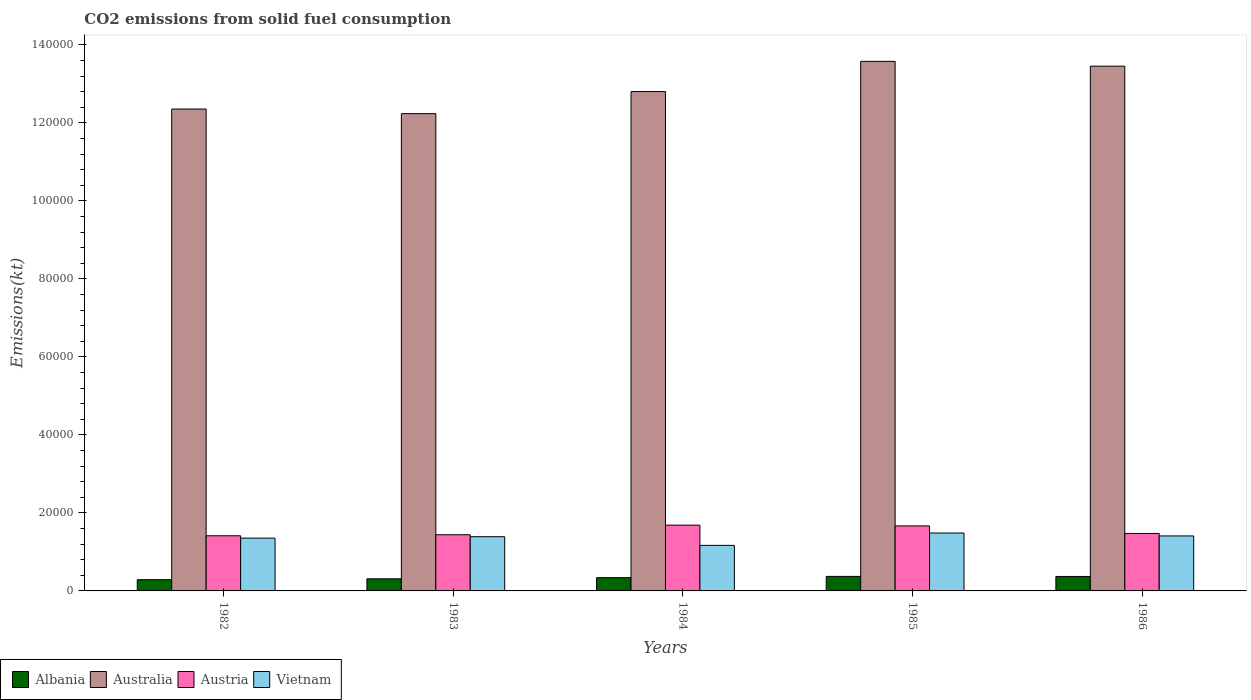How many groups of bars are there?
Offer a terse response. 5. Are the number of bars per tick equal to the number of legend labels?
Offer a terse response. Yes. Are the number of bars on each tick of the X-axis equal?
Offer a very short reply. Yes. How many bars are there on the 5th tick from the right?
Provide a succinct answer. 4. In how many cases, is the number of bars for a given year not equal to the number of legend labels?
Give a very brief answer. 0. What is the amount of CO2 emitted in Australia in 1986?
Your response must be concise. 1.35e+05. Across all years, what is the maximum amount of CO2 emitted in Austria?
Provide a short and direct response. 1.69e+04. Across all years, what is the minimum amount of CO2 emitted in Albania?
Provide a succinct answer. 2882.26. What is the total amount of CO2 emitted in Albania in the graph?
Your answer should be very brief. 1.68e+04. What is the difference between the amount of CO2 emitted in Austria in 1982 and that in 1983?
Your answer should be very brief. -267.69. What is the difference between the amount of CO2 emitted in Austria in 1982 and the amount of CO2 emitted in Australia in 1984?
Keep it short and to the point. -1.14e+05. What is the average amount of CO2 emitted in Australia per year?
Provide a short and direct response. 1.29e+05. In the year 1982, what is the difference between the amount of CO2 emitted in Vietnam and amount of CO2 emitted in Austria?
Your answer should be compact. -597.72. In how many years, is the amount of CO2 emitted in Austria greater than 20000 kt?
Provide a succinct answer. 0. What is the ratio of the amount of CO2 emitted in Albania in 1983 to that in 1985?
Give a very brief answer. 0.83. Is the difference between the amount of CO2 emitted in Vietnam in 1984 and 1986 greater than the difference between the amount of CO2 emitted in Austria in 1984 and 1986?
Your response must be concise. No. What is the difference between the highest and the second highest amount of CO2 emitted in Albania?
Offer a terse response. 14.67. What is the difference between the highest and the lowest amount of CO2 emitted in Austria?
Offer a terse response. 2728.25. Is it the case that in every year, the sum of the amount of CO2 emitted in Austria and amount of CO2 emitted in Australia is greater than the sum of amount of CO2 emitted in Albania and amount of CO2 emitted in Vietnam?
Offer a very short reply. Yes. What does the 4th bar from the left in 1985 represents?
Provide a short and direct response. Vietnam. How many bars are there?
Your response must be concise. 20. Are all the bars in the graph horizontal?
Offer a terse response. No. How many years are there in the graph?
Ensure brevity in your answer.  5. Are the values on the major ticks of Y-axis written in scientific E-notation?
Make the answer very short. No. Where does the legend appear in the graph?
Your response must be concise. Bottom left. How many legend labels are there?
Ensure brevity in your answer.  4. How are the legend labels stacked?
Make the answer very short. Horizontal. What is the title of the graph?
Your answer should be compact. CO2 emissions from solid fuel consumption. What is the label or title of the Y-axis?
Your response must be concise. Emissions(kt). What is the Emissions(kt) in Albania in 1982?
Your answer should be very brief. 2882.26. What is the Emissions(kt) in Australia in 1982?
Your response must be concise. 1.24e+05. What is the Emissions(kt) in Austria in 1982?
Provide a succinct answer. 1.41e+04. What is the Emissions(kt) of Vietnam in 1982?
Your answer should be compact. 1.35e+04. What is the Emissions(kt) in Albania in 1983?
Offer a very short reply. 3105.95. What is the Emissions(kt) of Australia in 1983?
Your answer should be compact. 1.22e+05. What is the Emissions(kt) of Austria in 1983?
Your response must be concise. 1.44e+04. What is the Emissions(kt) of Vietnam in 1983?
Your response must be concise. 1.39e+04. What is the Emissions(kt) of Albania in 1984?
Offer a terse response. 3402.98. What is the Emissions(kt) of Australia in 1984?
Ensure brevity in your answer.  1.28e+05. What is the Emissions(kt) in Austria in 1984?
Make the answer very short. 1.69e+04. What is the Emissions(kt) in Vietnam in 1984?
Make the answer very short. 1.17e+04. What is the Emissions(kt) of Albania in 1985?
Your response must be concise. 3725.67. What is the Emissions(kt) in Australia in 1985?
Make the answer very short. 1.36e+05. What is the Emissions(kt) of Austria in 1985?
Offer a terse response. 1.67e+04. What is the Emissions(kt) of Vietnam in 1985?
Make the answer very short. 1.49e+04. What is the Emissions(kt) of Albania in 1986?
Offer a terse response. 3711. What is the Emissions(kt) in Australia in 1986?
Give a very brief answer. 1.35e+05. What is the Emissions(kt) of Austria in 1986?
Offer a terse response. 1.47e+04. What is the Emissions(kt) of Vietnam in 1986?
Give a very brief answer. 1.41e+04. Across all years, what is the maximum Emissions(kt) of Albania?
Keep it short and to the point. 3725.67. Across all years, what is the maximum Emissions(kt) of Australia?
Offer a terse response. 1.36e+05. Across all years, what is the maximum Emissions(kt) of Austria?
Your response must be concise. 1.69e+04. Across all years, what is the maximum Emissions(kt) of Vietnam?
Your answer should be compact. 1.49e+04. Across all years, what is the minimum Emissions(kt) of Albania?
Your answer should be very brief. 2882.26. Across all years, what is the minimum Emissions(kt) of Australia?
Give a very brief answer. 1.22e+05. Across all years, what is the minimum Emissions(kt) in Austria?
Your response must be concise. 1.41e+04. Across all years, what is the minimum Emissions(kt) of Vietnam?
Give a very brief answer. 1.17e+04. What is the total Emissions(kt) in Albania in the graph?
Provide a short and direct response. 1.68e+04. What is the total Emissions(kt) of Australia in the graph?
Offer a terse response. 6.44e+05. What is the total Emissions(kt) of Austria in the graph?
Your response must be concise. 7.68e+04. What is the total Emissions(kt) in Vietnam in the graph?
Keep it short and to the point. 6.81e+04. What is the difference between the Emissions(kt) in Albania in 1982 and that in 1983?
Give a very brief answer. -223.69. What is the difference between the Emissions(kt) of Australia in 1982 and that in 1983?
Ensure brevity in your answer.  1184.44. What is the difference between the Emissions(kt) of Austria in 1982 and that in 1983?
Offer a terse response. -267.69. What is the difference between the Emissions(kt) in Vietnam in 1982 and that in 1983?
Your response must be concise. -359.37. What is the difference between the Emissions(kt) of Albania in 1982 and that in 1984?
Give a very brief answer. -520.71. What is the difference between the Emissions(kt) of Australia in 1982 and that in 1984?
Your answer should be compact. -4477.41. What is the difference between the Emissions(kt) in Austria in 1982 and that in 1984?
Your response must be concise. -2728.25. What is the difference between the Emissions(kt) in Vietnam in 1982 and that in 1984?
Your response must be concise. 1859.17. What is the difference between the Emissions(kt) in Albania in 1982 and that in 1985?
Your response must be concise. -843.41. What is the difference between the Emissions(kt) of Australia in 1982 and that in 1985?
Your response must be concise. -1.22e+04. What is the difference between the Emissions(kt) of Austria in 1982 and that in 1985?
Your answer should be compact. -2530.23. What is the difference between the Emissions(kt) of Vietnam in 1982 and that in 1985?
Make the answer very short. -1309.12. What is the difference between the Emissions(kt) of Albania in 1982 and that in 1986?
Provide a short and direct response. -828.74. What is the difference between the Emissions(kt) of Australia in 1982 and that in 1986?
Provide a succinct answer. -1.10e+04. What is the difference between the Emissions(kt) in Austria in 1982 and that in 1986?
Your answer should be compact. -597.72. What is the difference between the Emissions(kt) in Vietnam in 1982 and that in 1986?
Your answer should be very brief. -561.05. What is the difference between the Emissions(kt) in Albania in 1983 and that in 1984?
Give a very brief answer. -297.03. What is the difference between the Emissions(kt) in Australia in 1983 and that in 1984?
Make the answer very short. -5661.85. What is the difference between the Emissions(kt) in Austria in 1983 and that in 1984?
Your answer should be compact. -2460.56. What is the difference between the Emissions(kt) in Vietnam in 1983 and that in 1984?
Offer a terse response. 2218.53. What is the difference between the Emissions(kt) of Albania in 1983 and that in 1985?
Offer a terse response. -619.72. What is the difference between the Emissions(kt) of Australia in 1983 and that in 1985?
Provide a short and direct response. -1.34e+04. What is the difference between the Emissions(kt) of Austria in 1983 and that in 1985?
Your response must be concise. -2262.54. What is the difference between the Emissions(kt) of Vietnam in 1983 and that in 1985?
Your response must be concise. -949.75. What is the difference between the Emissions(kt) of Albania in 1983 and that in 1986?
Provide a short and direct response. -605.05. What is the difference between the Emissions(kt) of Australia in 1983 and that in 1986?
Offer a terse response. -1.22e+04. What is the difference between the Emissions(kt) in Austria in 1983 and that in 1986?
Offer a very short reply. -330.03. What is the difference between the Emissions(kt) of Vietnam in 1983 and that in 1986?
Offer a very short reply. -201.69. What is the difference between the Emissions(kt) in Albania in 1984 and that in 1985?
Provide a succinct answer. -322.7. What is the difference between the Emissions(kt) of Australia in 1984 and that in 1985?
Provide a short and direct response. -7748.37. What is the difference between the Emissions(kt) in Austria in 1984 and that in 1985?
Offer a terse response. 198.02. What is the difference between the Emissions(kt) of Vietnam in 1984 and that in 1985?
Offer a very short reply. -3168.29. What is the difference between the Emissions(kt) of Albania in 1984 and that in 1986?
Provide a succinct answer. -308.03. What is the difference between the Emissions(kt) in Australia in 1984 and that in 1986?
Keep it short and to the point. -6516.26. What is the difference between the Emissions(kt) in Austria in 1984 and that in 1986?
Your answer should be very brief. 2130.53. What is the difference between the Emissions(kt) of Vietnam in 1984 and that in 1986?
Ensure brevity in your answer.  -2420.22. What is the difference between the Emissions(kt) of Albania in 1985 and that in 1986?
Your answer should be compact. 14.67. What is the difference between the Emissions(kt) of Australia in 1985 and that in 1986?
Keep it short and to the point. 1232.11. What is the difference between the Emissions(kt) in Austria in 1985 and that in 1986?
Provide a succinct answer. 1932.51. What is the difference between the Emissions(kt) of Vietnam in 1985 and that in 1986?
Provide a succinct answer. 748.07. What is the difference between the Emissions(kt) of Albania in 1982 and the Emissions(kt) of Australia in 1983?
Make the answer very short. -1.20e+05. What is the difference between the Emissions(kt) in Albania in 1982 and the Emissions(kt) in Austria in 1983?
Make the answer very short. -1.15e+04. What is the difference between the Emissions(kt) in Albania in 1982 and the Emissions(kt) in Vietnam in 1983?
Ensure brevity in your answer.  -1.10e+04. What is the difference between the Emissions(kt) of Australia in 1982 and the Emissions(kt) of Austria in 1983?
Make the answer very short. 1.09e+05. What is the difference between the Emissions(kt) of Australia in 1982 and the Emissions(kt) of Vietnam in 1983?
Give a very brief answer. 1.10e+05. What is the difference between the Emissions(kt) of Austria in 1982 and the Emissions(kt) of Vietnam in 1983?
Your answer should be compact. 238.35. What is the difference between the Emissions(kt) of Albania in 1982 and the Emissions(kt) of Australia in 1984?
Provide a succinct answer. -1.25e+05. What is the difference between the Emissions(kt) in Albania in 1982 and the Emissions(kt) in Austria in 1984?
Your answer should be very brief. -1.40e+04. What is the difference between the Emissions(kt) of Albania in 1982 and the Emissions(kt) of Vietnam in 1984?
Ensure brevity in your answer.  -8800.8. What is the difference between the Emissions(kt) in Australia in 1982 and the Emissions(kt) in Austria in 1984?
Make the answer very short. 1.07e+05. What is the difference between the Emissions(kt) of Australia in 1982 and the Emissions(kt) of Vietnam in 1984?
Give a very brief answer. 1.12e+05. What is the difference between the Emissions(kt) of Austria in 1982 and the Emissions(kt) of Vietnam in 1984?
Offer a terse response. 2456.89. What is the difference between the Emissions(kt) in Albania in 1982 and the Emissions(kt) in Australia in 1985?
Your answer should be very brief. -1.33e+05. What is the difference between the Emissions(kt) in Albania in 1982 and the Emissions(kt) in Austria in 1985?
Provide a succinct answer. -1.38e+04. What is the difference between the Emissions(kt) in Albania in 1982 and the Emissions(kt) in Vietnam in 1985?
Keep it short and to the point. -1.20e+04. What is the difference between the Emissions(kt) in Australia in 1982 and the Emissions(kt) in Austria in 1985?
Offer a terse response. 1.07e+05. What is the difference between the Emissions(kt) of Australia in 1982 and the Emissions(kt) of Vietnam in 1985?
Give a very brief answer. 1.09e+05. What is the difference between the Emissions(kt) of Austria in 1982 and the Emissions(kt) of Vietnam in 1985?
Offer a terse response. -711.4. What is the difference between the Emissions(kt) in Albania in 1982 and the Emissions(kt) in Australia in 1986?
Your answer should be very brief. -1.32e+05. What is the difference between the Emissions(kt) of Albania in 1982 and the Emissions(kt) of Austria in 1986?
Provide a short and direct response. -1.19e+04. What is the difference between the Emissions(kt) in Albania in 1982 and the Emissions(kt) in Vietnam in 1986?
Your answer should be compact. -1.12e+04. What is the difference between the Emissions(kt) of Australia in 1982 and the Emissions(kt) of Austria in 1986?
Make the answer very short. 1.09e+05. What is the difference between the Emissions(kt) of Australia in 1982 and the Emissions(kt) of Vietnam in 1986?
Your response must be concise. 1.09e+05. What is the difference between the Emissions(kt) in Austria in 1982 and the Emissions(kt) in Vietnam in 1986?
Your answer should be very brief. 36.67. What is the difference between the Emissions(kt) in Albania in 1983 and the Emissions(kt) in Australia in 1984?
Ensure brevity in your answer.  -1.25e+05. What is the difference between the Emissions(kt) in Albania in 1983 and the Emissions(kt) in Austria in 1984?
Offer a terse response. -1.38e+04. What is the difference between the Emissions(kt) in Albania in 1983 and the Emissions(kt) in Vietnam in 1984?
Your answer should be very brief. -8577.11. What is the difference between the Emissions(kt) in Australia in 1983 and the Emissions(kt) in Austria in 1984?
Ensure brevity in your answer.  1.06e+05. What is the difference between the Emissions(kt) in Australia in 1983 and the Emissions(kt) in Vietnam in 1984?
Offer a terse response. 1.11e+05. What is the difference between the Emissions(kt) in Austria in 1983 and the Emissions(kt) in Vietnam in 1984?
Give a very brief answer. 2724.58. What is the difference between the Emissions(kt) of Albania in 1983 and the Emissions(kt) of Australia in 1985?
Offer a very short reply. -1.33e+05. What is the difference between the Emissions(kt) of Albania in 1983 and the Emissions(kt) of Austria in 1985?
Offer a very short reply. -1.36e+04. What is the difference between the Emissions(kt) of Albania in 1983 and the Emissions(kt) of Vietnam in 1985?
Offer a very short reply. -1.17e+04. What is the difference between the Emissions(kt) in Australia in 1983 and the Emissions(kt) in Austria in 1985?
Your response must be concise. 1.06e+05. What is the difference between the Emissions(kt) in Australia in 1983 and the Emissions(kt) in Vietnam in 1985?
Your response must be concise. 1.08e+05. What is the difference between the Emissions(kt) in Austria in 1983 and the Emissions(kt) in Vietnam in 1985?
Provide a succinct answer. -443.71. What is the difference between the Emissions(kt) of Albania in 1983 and the Emissions(kt) of Australia in 1986?
Your answer should be compact. -1.31e+05. What is the difference between the Emissions(kt) in Albania in 1983 and the Emissions(kt) in Austria in 1986?
Your response must be concise. -1.16e+04. What is the difference between the Emissions(kt) of Albania in 1983 and the Emissions(kt) of Vietnam in 1986?
Offer a terse response. -1.10e+04. What is the difference between the Emissions(kt) in Australia in 1983 and the Emissions(kt) in Austria in 1986?
Your answer should be very brief. 1.08e+05. What is the difference between the Emissions(kt) in Australia in 1983 and the Emissions(kt) in Vietnam in 1986?
Your answer should be very brief. 1.08e+05. What is the difference between the Emissions(kt) of Austria in 1983 and the Emissions(kt) of Vietnam in 1986?
Ensure brevity in your answer.  304.36. What is the difference between the Emissions(kt) of Albania in 1984 and the Emissions(kt) of Australia in 1985?
Offer a very short reply. -1.32e+05. What is the difference between the Emissions(kt) of Albania in 1984 and the Emissions(kt) of Austria in 1985?
Give a very brief answer. -1.33e+04. What is the difference between the Emissions(kt) in Albania in 1984 and the Emissions(kt) in Vietnam in 1985?
Make the answer very short. -1.14e+04. What is the difference between the Emissions(kt) of Australia in 1984 and the Emissions(kt) of Austria in 1985?
Make the answer very short. 1.11e+05. What is the difference between the Emissions(kt) of Australia in 1984 and the Emissions(kt) of Vietnam in 1985?
Give a very brief answer. 1.13e+05. What is the difference between the Emissions(kt) in Austria in 1984 and the Emissions(kt) in Vietnam in 1985?
Provide a short and direct response. 2016.85. What is the difference between the Emissions(kt) in Albania in 1984 and the Emissions(kt) in Australia in 1986?
Your response must be concise. -1.31e+05. What is the difference between the Emissions(kt) of Albania in 1984 and the Emissions(kt) of Austria in 1986?
Provide a succinct answer. -1.13e+04. What is the difference between the Emissions(kt) of Albania in 1984 and the Emissions(kt) of Vietnam in 1986?
Your answer should be compact. -1.07e+04. What is the difference between the Emissions(kt) in Australia in 1984 and the Emissions(kt) in Austria in 1986?
Provide a short and direct response. 1.13e+05. What is the difference between the Emissions(kt) in Australia in 1984 and the Emissions(kt) in Vietnam in 1986?
Your response must be concise. 1.14e+05. What is the difference between the Emissions(kt) in Austria in 1984 and the Emissions(kt) in Vietnam in 1986?
Your answer should be very brief. 2764.92. What is the difference between the Emissions(kt) of Albania in 1985 and the Emissions(kt) of Australia in 1986?
Provide a succinct answer. -1.31e+05. What is the difference between the Emissions(kt) in Albania in 1985 and the Emissions(kt) in Austria in 1986?
Your response must be concise. -1.10e+04. What is the difference between the Emissions(kt) of Albania in 1985 and the Emissions(kt) of Vietnam in 1986?
Your answer should be very brief. -1.04e+04. What is the difference between the Emissions(kt) of Australia in 1985 and the Emissions(kt) of Austria in 1986?
Offer a very short reply. 1.21e+05. What is the difference between the Emissions(kt) in Australia in 1985 and the Emissions(kt) in Vietnam in 1986?
Provide a succinct answer. 1.22e+05. What is the difference between the Emissions(kt) in Austria in 1985 and the Emissions(kt) in Vietnam in 1986?
Make the answer very short. 2566.9. What is the average Emissions(kt) of Albania per year?
Offer a terse response. 3365.57. What is the average Emissions(kt) of Australia per year?
Keep it short and to the point. 1.29e+05. What is the average Emissions(kt) in Austria per year?
Offer a terse response. 1.54e+04. What is the average Emissions(kt) of Vietnam per year?
Make the answer very short. 1.36e+04. In the year 1982, what is the difference between the Emissions(kt) of Albania and Emissions(kt) of Australia?
Provide a short and direct response. -1.21e+05. In the year 1982, what is the difference between the Emissions(kt) of Albania and Emissions(kt) of Austria?
Give a very brief answer. -1.13e+04. In the year 1982, what is the difference between the Emissions(kt) in Albania and Emissions(kt) in Vietnam?
Make the answer very short. -1.07e+04. In the year 1982, what is the difference between the Emissions(kt) in Australia and Emissions(kt) in Austria?
Your answer should be compact. 1.09e+05. In the year 1982, what is the difference between the Emissions(kt) of Australia and Emissions(kt) of Vietnam?
Keep it short and to the point. 1.10e+05. In the year 1982, what is the difference between the Emissions(kt) of Austria and Emissions(kt) of Vietnam?
Provide a succinct answer. 597.72. In the year 1983, what is the difference between the Emissions(kt) of Albania and Emissions(kt) of Australia?
Your response must be concise. -1.19e+05. In the year 1983, what is the difference between the Emissions(kt) of Albania and Emissions(kt) of Austria?
Your answer should be very brief. -1.13e+04. In the year 1983, what is the difference between the Emissions(kt) in Albania and Emissions(kt) in Vietnam?
Your response must be concise. -1.08e+04. In the year 1983, what is the difference between the Emissions(kt) in Australia and Emissions(kt) in Austria?
Keep it short and to the point. 1.08e+05. In the year 1983, what is the difference between the Emissions(kt) in Australia and Emissions(kt) in Vietnam?
Give a very brief answer. 1.08e+05. In the year 1983, what is the difference between the Emissions(kt) in Austria and Emissions(kt) in Vietnam?
Keep it short and to the point. 506.05. In the year 1984, what is the difference between the Emissions(kt) of Albania and Emissions(kt) of Australia?
Provide a succinct answer. -1.25e+05. In the year 1984, what is the difference between the Emissions(kt) of Albania and Emissions(kt) of Austria?
Offer a terse response. -1.35e+04. In the year 1984, what is the difference between the Emissions(kt) of Albania and Emissions(kt) of Vietnam?
Provide a succinct answer. -8280.09. In the year 1984, what is the difference between the Emissions(kt) of Australia and Emissions(kt) of Austria?
Your answer should be compact. 1.11e+05. In the year 1984, what is the difference between the Emissions(kt) in Australia and Emissions(kt) in Vietnam?
Ensure brevity in your answer.  1.16e+05. In the year 1984, what is the difference between the Emissions(kt) in Austria and Emissions(kt) in Vietnam?
Your response must be concise. 5185.14. In the year 1985, what is the difference between the Emissions(kt) of Albania and Emissions(kt) of Australia?
Your response must be concise. -1.32e+05. In the year 1985, what is the difference between the Emissions(kt) in Albania and Emissions(kt) in Austria?
Make the answer very short. -1.29e+04. In the year 1985, what is the difference between the Emissions(kt) in Albania and Emissions(kt) in Vietnam?
Make the answer very short. -1.11e+04. In the year 1985, what is the difference between the Emissions(kt) in Australia and Emissions(kt) in Austria?
Offer a very short reply. 1.19e+05. In the year 1985, what is the difference between the Emissions(kt) of Australia and Emissions(kt) of Vietnam?
Offer a very short reply. 1.21e+05. In the year 1985, what is the difference between the Emissions(kt) of Austria and Emissions(kt) of Vietnam?
Your response must be concise. 1818.83. In the year 1986, what is the difference between the Emissions(kt) of Albania and Emissions(kt) of Australia?
Offer a terse response. -1.31e+05. In the year 1986, what is the difference between the Emissions(kt) in Albania and Emissions(kt) in Austria?
Provide a succinct answer. -1.10e+04. In the year 1986, what is the difference between the Emissions(kt) in Albania and Emissions(kt) in Vietnam?
Make the answer very short. -1.04e+04. In the year 1986, what is the difference between the Emissions(kt) in Australia and Emissions(kt) in Austria?
Offer a terse response. 1.20e+05. In the year 1986, what is the difference between the Emissions(kt) in Australia and Emissions(kt) in Vietnam?
Give a very brief answer. 1.20e+05. In the year 1986, what is the difference between the Emissions(kt) of Austria and Emissions(kt) of Vietnam?
Keep it short and to the point. 634.39. What is the ratio of the Emissions(kt) in Albania in 1982 to that in 1983?
Ensure brevity in your answer.  0.93. What is the ratio of the Emissions(kt) of Australia in 1982 to that in 1983?
Keep it short and to the point. 1.01. What is the ratio of the Emissions(kt) of Austria in 1982 to that in 1983?
Your response must be concise. 0.98. What is the ratio of the Emissions(kt) of Vietnam in 1982 to that in 1983?
Keep it short and to the point. 0.97. What is the ratio of the Emissions(kt) of Albania in 1982 to that in 1984?
Your answer should be very brief. 0.85. What is the ratio of the Emissions(kt) in Austria in 1982 to that in 1984?
Keep it short and to the point. 0.84. What is the ratio of the Emissions(kt) in Vietnam in 1982 to that in 1984?
Give a very brief answer. 1.16. What is the ratio of the Emissions(kt) in Albania in 1982 to that in 1985?
Offer a very short reply. 0.77. What is the ratio of the Emissions(kt) of Australia in 1982 to that in 1985?
Your answer should be very brief. 0.91. What is the ratio of the Emissions(kt) of Austria in 1982 to that in 1985?
Your answer should be compact. 0.85. What is the ratio of the Emissions(kt) in Vietnam in 1982 to that in 1985?
Keep it short and to the point. 0.91. What is the ratio of the Emissions(kt) of Albania in 1982 to that in 1986?
Provide a short and direct response. 0.78. What is the ratio of the Emissions(kt) of Australia in 1982 to that in 1986?
Offer a terse response. 0.92. What is the ratio of the Emissions(kt) in Austria in 1982 to that in 1986?
Offer a very short reply. 0.96. What is the ratio of the Emissions(kt) in Vietnam in 1982 to that in 1986?
Give a very brief answer. 0.96. What is the ratio of the Emissions(kt) in Albania in 1983 to that in 1984?
Provide a short and direct response. 0.91. What is the ratio of the Emissions(kt) of Australia in 1983 to that in 1984?
Your answer should be compact. 0.96. What is the ratio of the Emissions(kt) in Austria in 1983 to that in 1984?
Offer a terse response. 0.85. What is the ratio of the Emissions(kt) of Vietnam in 1983 to that in 1984?
Keep it short and to the point. 1.19. What is the ratio of the Emissions(kt) in Albania in 1983 to that in 1985?
Provide a short and direct response. 0.83. What is the ratio of the Emissions(kt) in Australia in 1983 to that in 1985?
Your answer should be compact. 0.9. What is the ratio of the Emissions(kt) of Austria in 1983 to that in 1985?
Provide a short and direct response. 0.86. What is the ratio of the Emissions(kt) of Vietnam in 1983 to that in 1985?
Your response must be concise. 0.94. What is the ratio of the Emissions(kt) of Albania in 1983 to that in 1986?
Offer a very short reply. 0.84. What is the ratio of the Emissions(kt) of Australia in 1983 to that in 1986?
Make the answer very short. 0.91. What is the ratio of the Emissions(kt) of Austria in 1983 to that in 1986?
Provide a succinct answer. 0.98. What is the ratio of the Emissions(kt) in Vietnam in 1983 to that in 1986?
Offer a very short reply. 0.99. What is the ratio of the Emissions(kt) in Albania in 1984 to that in 1985?
Provide a short and direct response. 0.91. What is the ratio of the Emissions(kt) in Australia in 1984 to that in 1985?
Offer a terse response. 0.94. What is the ratio of the Emissions(kt) in Austria in 1984 to that in 1985?
Provide a succinct answer. 1.01. What is the ratio of the Emissions(kt) in Vietnam in 1984 to that in 1985?
Make the answer very short. 0.79. What is the ratio of the Emissions(kt) of Albania in 1984 to that in 1986?
Your response must be concise. 0.92. What is the ratio of the Emissions(kt) of Australia in 1984 to that in 1986?
Provide a succinct answer. 0.95. What is the ratio of the Emissions(kt) in Austria in 1984 to that in 1986?
Your answer should be very brief. 1.14. What is the ratio of the Emissions(kt) in Vietnam in 1984 to that in 1986?
Give a very brief answer. 0.83. What is the ratio of the Emissions(kt) in Albania in 1985 to that in 1986?
Ensure brevity in your answer.  1. What is the ratio of the Emissions(kt) of Australia in 1985 to that in 1986?
Offer a very short reply. 1.01. What is the ratio of the Emissions(kt) of Austria in 1985 to that in 1986?
Give a very brief answer. 1.13. What is the ratio of the Emissions(kt) of Vietnam in 1985 to that in 1986?
Offer a very short reply. 1.05. What is the difference between the highest and the second highest Emissions(kt) in Albania?
Provide a short and direct response. 14.67. What is the difference between the highest and the second highest Emissions(kt) of Australia?
Give a very brief answer. 1232.11. What is the difference between the highest and the second highest Emissions(kt) in Austria?
Offer a terse response. 198.02. What is the difference between the highest and the second highest Emissions(kt) in Vietnam?
Give a very brief answer. 748.07. What is the difference between the highest and the lowest Emissions(kt) in Albania?
Provide a short and direct response. 843.41. What is the difference between the highest and the lowest Emissions(kt) in Australia?
Ensure brevity in your answer.  1.34e+04. What is the difference between the highest and the lowest Emissions(kt) of Austria?
Offer a terse response. 2728.25. What is the difference between the highest and the lowest Emissions(kt) of Vietnam?
Provide a succinct answer. 3168.29. 